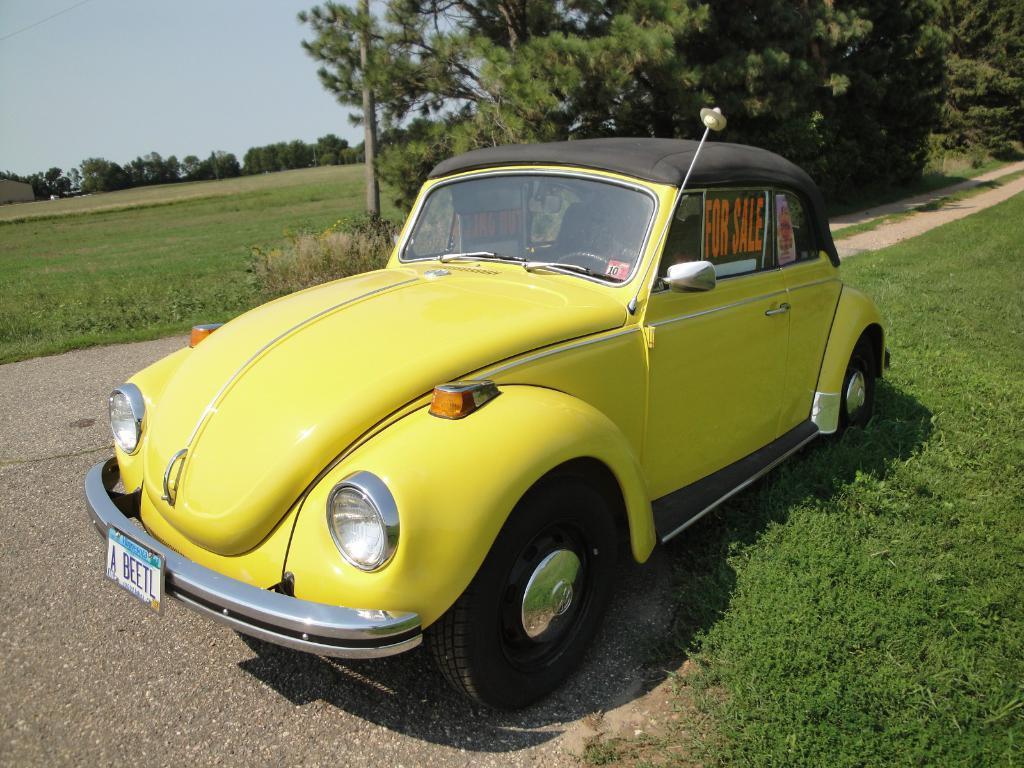In one or two sentences, can you explain what this image depicts? In this picture we can see a car on the ground with posters on it, grass, trees, pole and in the background we can see the sky. 